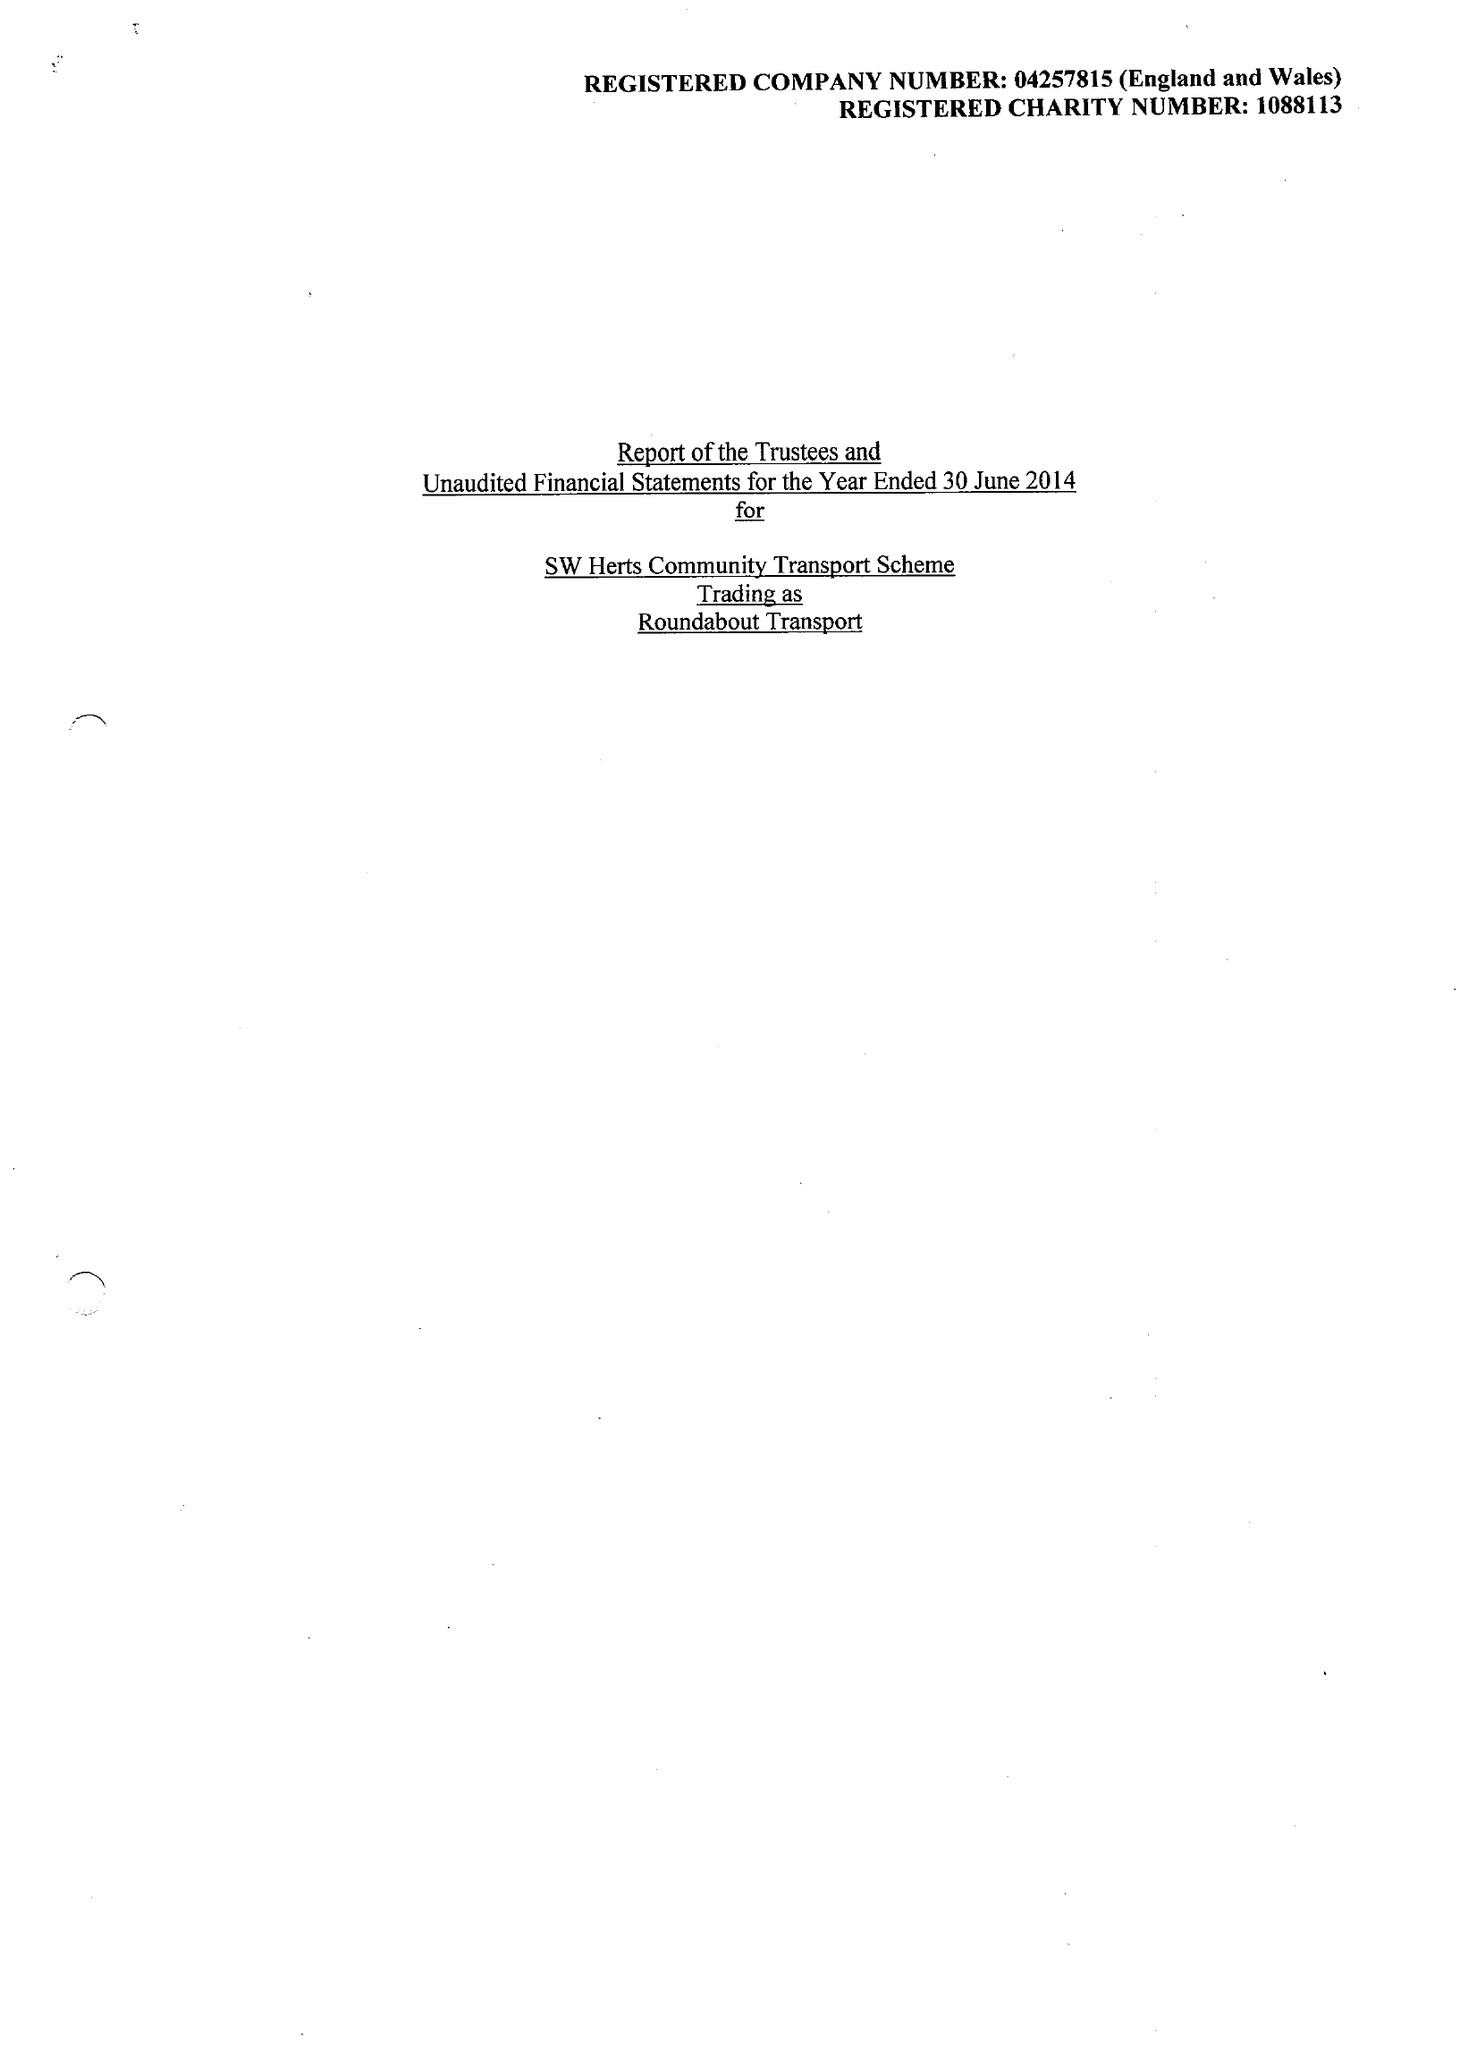What is the value for the report_date?
Answer the question using a single word or phrase. 2014-06-30 